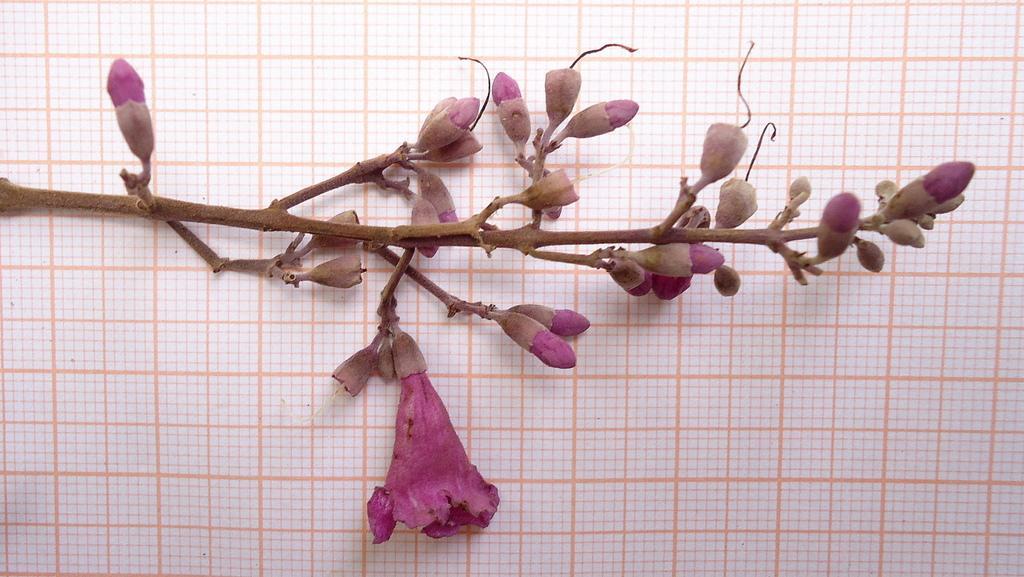Could you give a brief overview of what you see in this image? In this image, I can see a stem with a flower and buds. In the background, It is looking like a paper. 